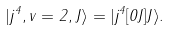Convert formula to latex. <formula><loc_0><loc_0><loc_500><loc_500>| j ^ { 4 } , v = 2 , J \rangle = | j ^ { 4 } [ 0 J ] J \rangle .</formula> 